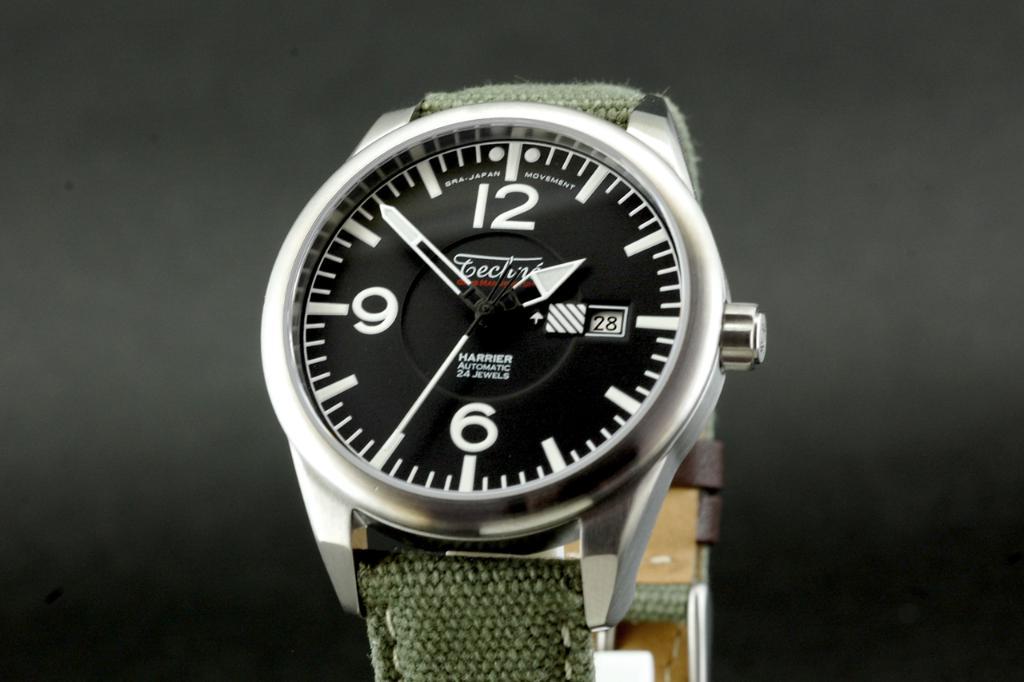Who made the watch?
Keep it short and to the point. Unanswerable. What time is it?
Your answer should be compact. 1:52. 